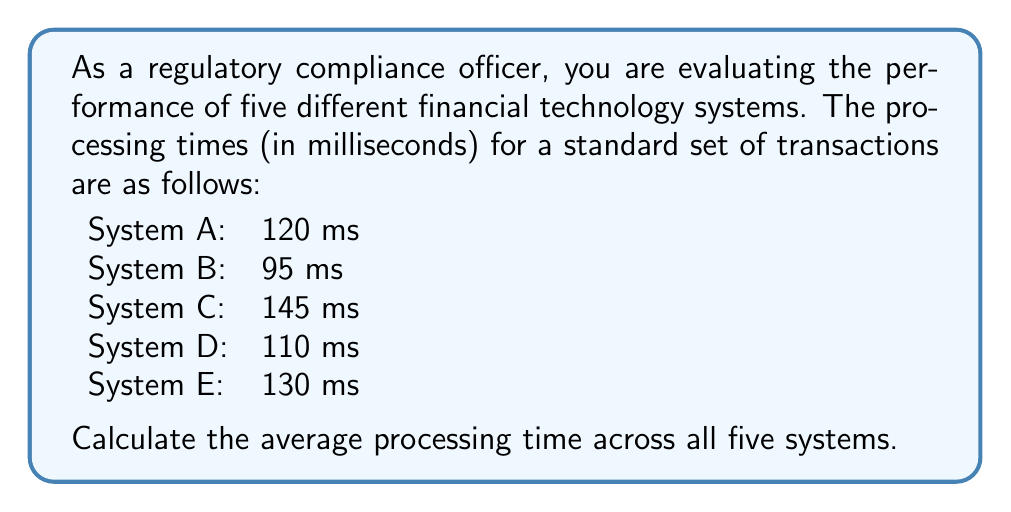What is the answer to this math problem? To calculate the average processing time, we need to follow these steps:

1. Sum up all the processing times:
   $$120 + 95 + 145 + 110 + 130 = 600\text{ ms}$$

2. Count the total number of systems:
   There are 5 systems in total.

3. Apply the formula for calculating the average:
   $$\text{Average} = \frac{\text{Sum of all values}}{\text{Number of values}}$$

   In this case:
   $$\text{Average} = \frac{600\text{ ms}}{5} = 120\text{ ms}$$

Therefore, the average processing time across all five financial technology systems is 120 milliseconds.
Answer: $120\text{ ms}$ 